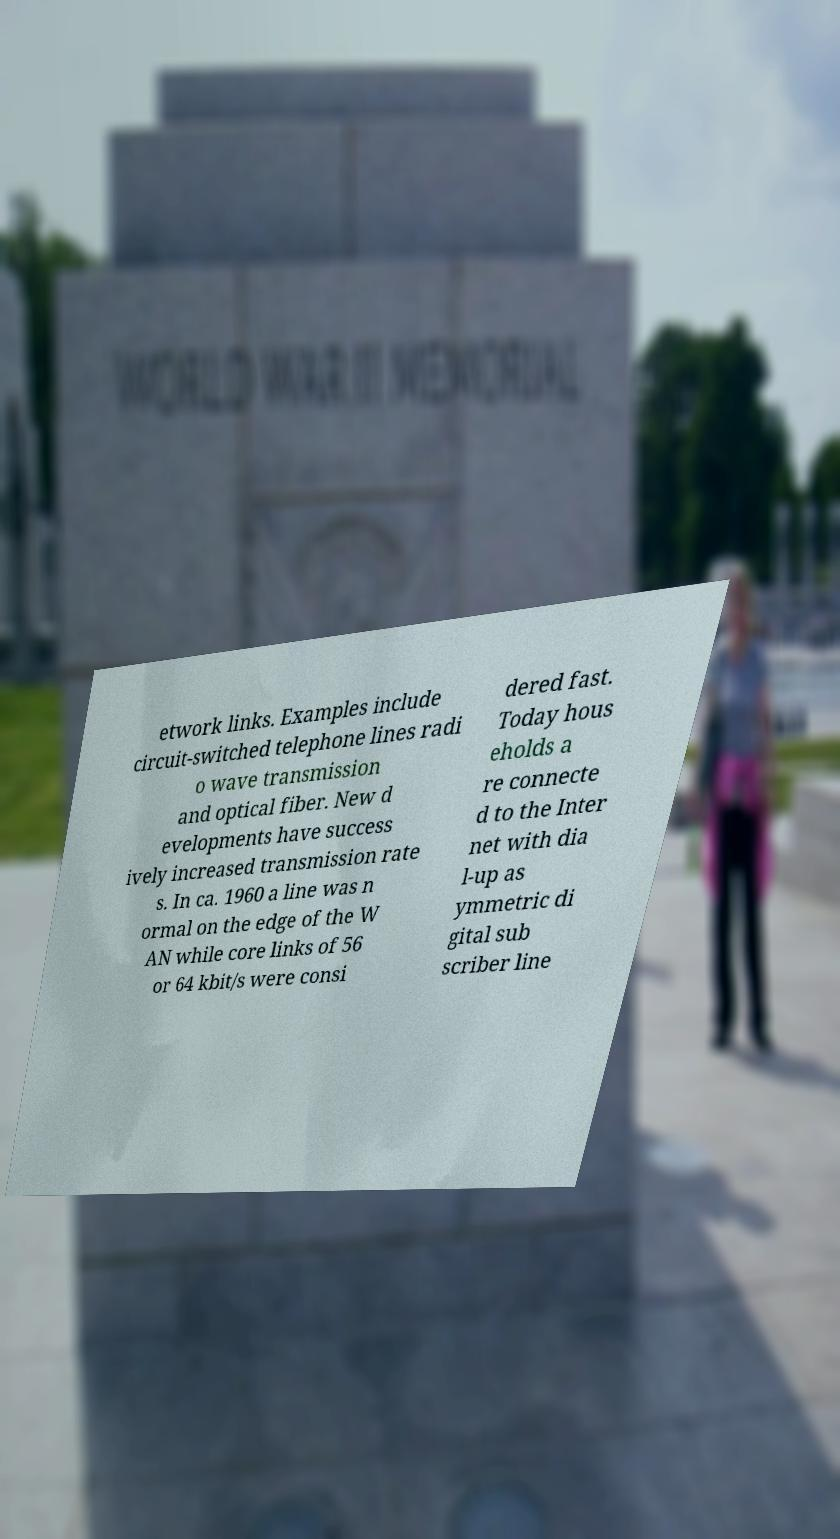Can you accurately transcribe the text from the provided image for me? etwork links. Examples include circuit-switched telephone lines radi o wave transmission and optical fiber. New d evelopments have success ively increased transmission rate s. In ca. 1960 a line was n ormal on the edge of the W AN while core links of 56 or 64 kbit/s were consi dered fast. Today hous eholds a re connecte d to the Inter net with dia l-up as ymmetric di gital sub scriber line 